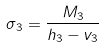Convert formula to latex. <formula><loc_0><loc_0><loc_500><loc_500>\sigma _ { 3 } = \frac { M _ { 3 } } { h _ { 3 } - v _ { 3 } }</formula> 